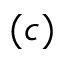Convert formula to latex. <formula><loc_0><loc_0><loc_500><loc_500>( c )</formula> 